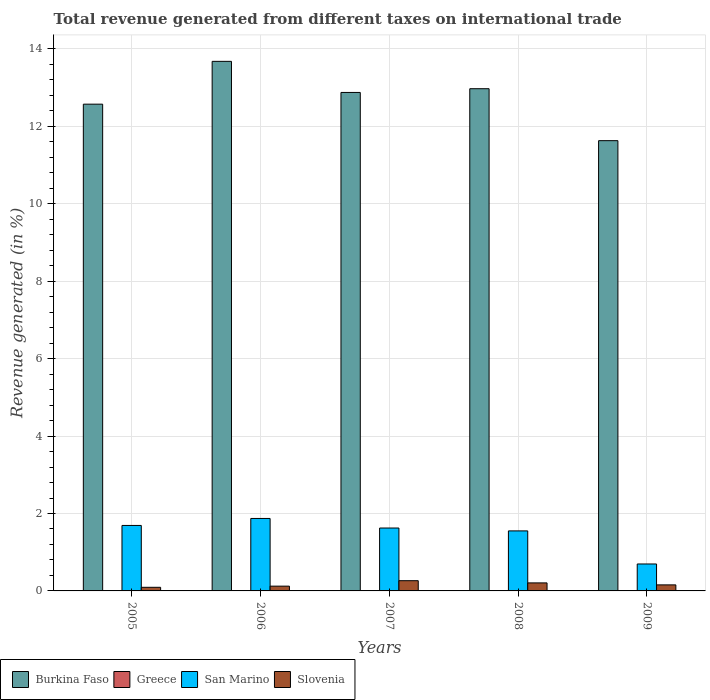How many different coloured bars are there?
Provide a succinct answer. 4. How many bars are there on the 5th tick from the left?
Make the answer very short. 4. How many bars are there on the 4th tick from the right?
Your answer should be compact. 4. What is the total revenue generated in San Marino in 2009?
Give a very brief answer. 0.7. Across all years, what is the maximum total revenue generated in Burkina Faso?
Offer a very short reply. 13.68. Across all years, what is the minimum total revenue generated in Burkina Faso?
Provide a short and direct response. 11.63. In which year was the total revenue generated in Burkina Faso minimum?
Make the answer very short. 2009. What is the total total revenue generated in Burkina Faso in the graph?
Your answer should be compact. 63.73. What is the difference between the total revenue generated in Burkina Faso in 2007 and that in 2009?
Give a very brief answer. 1.25. What is the difference between the total revenue generated in Greece in 2007 and the total revenue generated in San Marino in 2008?
Your answer should be compact. -1.54. What is the average total revenue generated in Burkina Faso per year?
Your answer should be very brief. 12.75. In the year 2005, what is the difference between the total revenue generated in Greece and total revenue generated in Slovenia?
Give a very brief answer. -0.09. What is the ratio of the total revenue generated in Burkina Faso in 2005 to that in 2007?
Provide a short and direct response. 0.98. What is the difference between the highest and the second highest total revenue generated in Burkina Faso?
Ensure brevity in your answer.  0.71. What is the difference between the highest and the lowest total revenue generated in Burkina Faso?
Make the answer very short. 2.05. Is the sum of the total revenue generated in San Marino in 2007 and 2008 greater than the maximum total revenue generated in Slovenia across all years?
Ensure brevity in your answer.  Yes. Is it the case that in every year, the sum of the total revenue generated in Burkina Faso and total revenue generated in Greece is greater than the sum of total revenue generated in Slovenia and total revenue generated in San Marino?
Your response must be concise. Yes. What does the 3rd bar from the left in 2008 represents?
Offer a very short reply. San Marino. What does the 1st bar from the right in 2006 represents?
Your response must be concise. Slovenia. How many years are there in the graph?
Keep it short and to the point. 5. What is the difference between two consecutive major ticks on the Y-axis?
Ensure brevity in your answer.  2. Are the values on the major ticks of Y-axis written in scientific E-notation?
Keep it short and to the point. No. Does the graph contain any zero values?
Keep it short and to the point. No. Does the graph contain grids?
Provide a short and direct response. Yes. What is the title of the graph?
Your answer should be very brief. Total revenue generated from different taxes on international trade. Does "Thailand" appear as one of the legend labels in the graph?
Ensure brevity in your answer.  No. What is the label or title of the Y-axis?
Offer a terse response. Revenue generated (in %). What is the Revenue generated (in %) in Burkina Faso in 2005?
Your answer should be compact. 12.57. What is the Revenue generated (in %) of Greece in 2005?
Ensure brevity in your answer.  0. What is the Revenue generated (in %) in San Marino in 2005?
Your answer should be compact. 1.69. What is the Revenue generated (in %) in Slovenia in 2005?
Provide a succinct answer. 0.09. What is the Revenue generated (in %) in Burkina Faso in 2006?
Your response must be concise. 13.68. What is the Revenue generated (in %) of Greece in 2006?
Offer a terse response. 0.01. What is the Revenue generated (in %) in San Marino in 2006?
Your response must be concise. 1.87. What is the Revenue generated (in %) of Slovenia in 2006?
Your answer should be very brief. 0.12. What is the Revenue generated (in %) in Burkina Faso in 2007?
Offer a terse response. 12.88. What is the Revenue generated (in %) in Greece in 2007?
Keep it short and to the point. 0.01. What is the Revenue generated (in %) of San Marino in 2007?
Make the answer very short. 1.62. What is the Revenue generated (in %) in Slovenia in 2007?
Give a very brief answer. 0.26. What is the Revenue generated (in %) in Burkina Faso in 2008?
Your answer should be compact. 12.97. What is the Revenue generated (in %) of Greece in 2008?
Your response must be concise. 0. What is the Revenue generated (in %) of San Marino in 2008?
Keep it short and to the point. 1.55. What is the Revenue generated (in %) of Slovenia in 2008?
Your answer should be very brief. 0.21. What is the Revenue generated (in %) in Burkina Faso in 2009?
Your response must be concise. 11.63. What is the Revenue generated (in %) of Greece in 2009?
Provide a succinct answer. 0. What is the Revenue generated (in %) in San Marino in 2009?
Keep it short and to the point. 0.7. What is the Revenue generated (in %) in Slovenia in 2009?
Your response must be concise. 0.16. Across all years, what is the maximum Revenue generated (in %) in Burkina Faso?
Ensure brevity in your answer.  13.68. Across all years, what is the maximum Revenue generated (in %) of Greece?
Your answer should be very brief. 0.01. Across all years, what is the maximum Revenue generated (in %) of San Marino?
Offer a very short reply. 1.87. Across all years, what is the maximum Revenue generated (in %) of Slovenia?
Keep it short and to the point. 0.26. Across all years, what is the minimum Revenue generated (in %) in Burkina Faso?
Your answer should be very brief. 11.63. Across all years, what is the minimum Revenue generated (in %) of Greece?
Provide a succinct answer. 0. Across all years, what is the minimum Revenue generated (in %) of San Marino?
Offer a terse response. 0.7. Across all years, what is the minimum Revenue generated (in %) in Slovenia?
Offer a very short reply. 0.09. What is the total Revenue generated (in %) in Burkina Faso in the graph?
Provide a short and direct response. 63.73. What is the total Revenue generated (in %) in Greece in the graph?
Provide a short and direct response. 0.02. What is the total Revenue generated (in %) in San Marino in the graph?
Offer a terse response. 7.43. What is the total Revenue generated (in %) in Slovenia in the graph?
Offer a terse response. 0.84. What is the difference between the Revenue generated (in %) in Burkina Faso in 2005 and that in 2006?
Keep it short and to the point. -1.11. What is the difference between the Revenue generated (in %) in Greece in 2005 and that in 2006?
Keep it short and to the point. -0. What is the difference between the Revenue generated (in %) in San Marino in 2005 and that in 2006?
Your response must be concise. -0.18. What is the difference between the Revenue generated (in %) of Slovenia in 2005 and that in 2006?
Provide a succinct answer. -0.03. What is the difference between the Revenue generated (in %) in Burkina Faso in 2005 and that in 2007?
Give a very brief answer. -0.3. What is the difference between the Revenue generated (in %) in Greece in 2005 and that in 2007?
Your response must be concise. -0. What is the difference between the Revenue generated (in %) in San Marino in 2005 and that in 2007?
Your response must be concise. 0.07. What is the difference between the Revenue generated (in %) in Slovenia in 2005 and that in 2007?
Offer a terse response. -0.17. What is the difference between the Revenue generated (in %) in Burkina Faso in 2005 and that in 2008?
Provide a succinct answer. -0.4. What is the difference between the Revenue generated (in %) in Greece in 2005 and that in 2008?
Your answer should be very brief. 0. What is the difference between the Revenue generated (in %) in San Marino in 2005 and that in 2008?
Keep it short and to the point. 0.14. What is the difference between the Revenue generated (in %) of Slovenia in 2005 and that in 2008?
Provide a short and direct response. -0.11. What is the difference between the Revenue generated (in %) in Burkina Faso in 2005 and that in 2009?
Ensure brevity in your answer.  0.94. What is the difference between the Revenue generated (in %) in Greece in 2005 and that in 2009?
Offer a very short reply. 0. What is the difference between the Revenue generated (in %) in San Marino in 2005 and that in 2009?
Provide a succinct answer. 1. What is the difference between the Revenue generated (in %) in Slovenia in 2005 and that in 2009?
Your answer should be very brief. -0.06. What is the difference between the Revenue generated (in %) of Burkina Faso in 2006 and that in 2007?
Give a very brief answer. 0.8. What is the difference between the Revenue generated (in %) in Greece in 2006 and that in 2007?
Your answer should be compact. -0. What is the difference between the Revenue generated (in %) of San Marino in 2006 and that in 2007?
Your answer should be very brief. 0.25. What is the difference between the Revenue generated (in %) in Slovenia in 2006 and that in 2007?
Give a very brief answer. -0.14. What is the difference between the Revenue generated (in %) in Burkina Faso in 2006 and that in 2008?
Keep it short and to the point. 0.71. What is the difference between the Revenue generated (in %) of Greece in 2006 and that in 2008?
Your response must be concise. 0. What is the difference between the Revenue generated (in %) in San Marino in 2006 and that in 2008?
Offer a very short reply. 0.32. What is the difference between the Revenue generated (in %) of Slovenia in 2006 and that in 2008?
Your response must be concise. -0.08. What is the difference between the Revenue generated (in %) in Burkina Faso in 2006 and that in 2009?
Your response must be concise. 2.05. What is the difference between the Revenue generated (in %) in Greece in 2006 and that in 2009?
Make the answer very short. 0. What is the difference between the Revenue generated (in %) in San Marino in 2006 and that in 2009?
Make the answer very short. 1.18. What is the difference between the Revenue generated (in %) of Slovenia in 2006 and that in 2009?
Your response must be concise. -0.03. What is the difference between the Revenue generated (in %) of Burkina Faso in 2007 and that in 2008?
Your response must be concise. -0.1. What is the difference between the Revenue generated (in %) in Greece in 2007 and that in 2008?
Make the answer very short. 0.01. What is the difference between the Revenue generated (in %) of San Marino in 2007 and that in 2008?
Offer a very short reply. 0.07. What is the difference between the Revenue generated (in %) of Slovenia in 2007 and that in 2008?
Ensure brevity in your answer.  0.06. What is the difference between the Revenue generated (in %) in Burkina Faso in 2007 and that in 2009?
Make the answer very short. 1.25. What is the difference between the Revenue generated (in %) in Greece in 2007 and that in 2009?
Keep it short and to the point. 0.01. What is the difference between the Revenue generated (in %) in San Marino in 2007 and that in 2009?
Your answer should be compact. 0.93. What is the difference between the Revenue generated (in %) of Slovenia in 2007 and that in 2009?
Ensure brevity in your answer.  0.11. What is the difference between the Revenue generated (in %) in Burkina Faso in 2008 and that in 2009?
Provide a short and direct response. 1.34. What is the difference between the Revenue generated (in %) in San Marino in 2008 and that in 2009?
Give a very brief answer. 0.85. What is the difference between the Revenue generated (in %) of Slovenia in 2008 and that in 2009?
Give a very brief answer. 0.05. What is the difference between the Revenue generated (in %) in Burkina Faso in 2005 and the Revenue generated (in %) in Greece in 2006?
Keep it short and to the point. 12.57. What is the difference between the Revenue generated (in %) of Burkina Faso in 2005 and the Revenue generated (in %) of San Marino in 2006?
Keep it short and to the point. 10.7. What is the difference between the Revenue generated (in %) of Burkina Faso in 2005 and the Revenue generated (in %) of Slovenia in 2006?
Offer a terse response. 12.45. What is the difference between the Revenue generated (in %) of Greece in 2005 and the Revenue generated (in %) of San Marino in 2006?
Keep it short and to the point. -1.87. What is the difference between the Revenue generated (in %) of Greece in 2005 and the Revenue generated (in %) of Slovenia in 2006?
Your answer should be compact. -0.12. What is the difference between the Revenue generated (in %) of San Marino in 2005 and the Revenue generated (in %) of Slovenia in 2006?
Give a very brief answer. 1.57. What is the difference between the Revenue generated (in %) of Burkina Faso in 2005 and the Revenue generated (in %) of Greece in 2007?
Make the answer very short. 12.56. What is the difference between the Revenue generated (in %) of Burkina Faso in 2005 and the Revenue generated (in %) of San Marino in 2007?
Your answer should be very brief. 10.95. What is the difference between the Revenue generated (in %) in Burkina Faso in 2005 and the Revenue generated (in %) in Slovenia in 2007?
Your answer should be very brief. 12.31. What is the difference between the Revenue generated (in %) in Greece in 2005 and the Revenue generated (in %) in San Marino in 2007?
Your answer should be very brief. -1.62. What is the difference between the Revenue generated (in %) of Greece in 2005 and the Revenue generated (in %) of Slovenia in 2007?
Keep it short and to the point. -0.26. What is the difference between the Revenue generated (in %) of San Marino in 2005 and the Revenue generated (in %) of Slovenia in 2007?
Make the answer very short. 1.43. What is the difference between the Revenue generated (in %) of Burkina Faso in 2005 and the Revenue generated (in %) of Greece in 2008?
Ensure brevity in your answer.  12.57. What is the difference between the Revenue generated (in %) in Burkina Faso in 2005 and the Revenue generated (in %) in San Marino in 2008?
Offer a very short reply. 11.02. What is the difference between the Revenue generated (in %) in Burkina Faso in 2005 and the Revenue generated (in %) in Slovenia in 2008?
Provide a succinct answer. 12.37. What is the difference between the Revenue generated (in %) of Greece in 2005 and the Revenue generated (in %) of San Marino in 2008?
Offer a very short reply. -1.55. What is the difference between the Revenue generated (in %) of Greece in 2005 and the Revenue generated (in %) of Slovenia in 2008?
Your answer should be very brief. -0.2. What is the difference between the Revenue generated (in %) in San Marino in 2005 and the Revenue generated (in %) in Slovenia in 2008?
Give a very brief answer. 1.48. What is the difference between the Revenue generated (in %) in Burkina Faso in 2005 and the Revenue generated (in %) in Greece in 2009?
Provide a short and direct response. 12.57. What is the difference between the Revenue generated (in %) in Burkina Faso in 2005 and the Revenue generated (in %) in San Marino in 2009?
Ensure brevity in your answer.  11.88. What is the difference between the Revenue generated (in %) in Burkina Faso in 2005 and the Revenue generated (in %) in Slovenia in 2009?
Make the answer very short. 12.42. What is the difference between the Revenue generated (in %) in Greece in 2005 and the Revenue generated (in %) in San Marino in 2009?
Your answer should be compact. -0.69. What is the difference between the Revenue generated (in %) in Greece in 2005 and the Revenue generated (in %) in Slovenia in 2009?
Keep it short and to the point. -0.15. What is the difference between the Revenue generated (in %) in San Marino in 2005 and the Revenue generated (in %) in Slovenia in 2009?
Provide a succinct answer. 1.54. What is the difference between the Revenue generated (in %) of Burkina Faso in 2006 and the Revenue generated (in %) of Greece in 2007?
Make the answer very short. 13.67. What is the difference between the Revenue generated (in %) in Burkina Faso in 2006 and the Revenue generated (in %) in San Marino in 2007?
Keep it short and to the point. 12.05. What is the difference between the Revenue generated (in %) in Burkina Faso in 2006 and the Revenue generated (in %) in Slovenia in 2007?
Ensure brevity in your answer.  13.41. What is the difference between the Revenue generated (in %) in Greece in 2006 and the Revenue generated (in %) in San Marino in 2007?
Offer a terse response. -1.62. What is the difference between the Revenue generated (in %) of Greece in 2006 and the Revenue generated (in %) of Slovenia in 2007?
Offer a terse response. -0.26. What is the difference between the Revenue generated (in %) in San Marino in 2006 and the Revenue generated (in %) in Slovenia in 2007?
Ensure brevity in your answer.  1.61. What is the difference between the Revenue generated (in %) in Burkina Faso in 2006 and the Revenue generated (in %) in Greece in 2008?
Your answer should be very brief. 13.68. What is the difference between the Revenue generated (in %) of Burkina Faso in 2006 and the Revenue generated (in %) of San Marino in 2008?
Your response must be concise. 12.13. What is the difference between the Revenue generated (in %) of Burkina Faso in 2006 and the Revenue generated (in %) of Slovenia in 2008?
Offer a terse response. 13.47. What is the difference between the Revenue generated (in %) in Greece in 2006 and the Revenue generated (in %) in San Marino in 2008?
Provide a short and direct response. -1.55. What is the difference between the Revenue generated (in %) of Greece in 2006 and the Revenue generated (in %) of Slovenia in 2008?
Make the answer very short. -0.2. What is the difference between the Revenue generated (in %) in San Marino in 2006 and the Revenue generated (in %) in Slovenia in 2008?
Your answer should be compact. 1.66. What is the difference between the Revenue generated (in %) of Burkina Faso in 2006 and the Revenue generated (in %) of Greece in 2009?
Your response must be concise. 13.68. What is the difference between the Revenue generated (in %) in Burkina Faso in 2006 and the Revenue generated (in %) in San Marino in 2009?
Your answer should be compact. 12.98. What is the difference between the Revenue generated (in %) of Burkina Faso in 2006 and the Revenue generated (in %) of Slovenia in 2009?
Give a very brief answer. 13.52. What is the difference between the Revenue generated (in %) of Greece in 2006 and the Revenue generated (in %) of San Marino in 2009?
Provide a short and direct response. -0.69. What is the difference between the Revenue generated (in %) of Greece in 2006 and the Revenue generated (in %) of Slovenia in 2009?
Your response must be concise. -0.15. What is the difference between the Revenue generated (in %) in San Marino in 2006 and the Revenue generated (in %) in Slovenia in 2009?
Your response must be concise. 1.72. What is the difference between the Revenue generated (in %) in Burkina Faso in 2007 and the Revenue generated (in %) in Greece in 2008?
Keep it short and to the point. 12.87. What is the difference between the Revenue generated (in %) in Burkina Faso in 2007 and the Revenue generated (in %) in San Marino in 2008?
Your response must be concise. 11.33. What is the difference between the Revenue generated (in %) of Burkina Faso in 2007 and the Revenue generated (in %) of Slovenia in 2008?
Offer a terse response. 12.67. What is the difference between the Revenue generated (in %) of Greece in 2007 and the Revenue generated (in %) of San Marino in 2008?
Offer a terse response. -1.54. What is the difference between the Revenue generated (in %) in Greece in 2007 and the Revenue generated (in %) in Slovenia in 2008?
Make the answer very short. -0.2. What is the difference between the Revenue generated (in %) in San Marino in 2007 and the Revenue generated (in %) in Slovenia in 2008?
Offer a very short reply. 1.42. What is the difference between the Revenue generated (in %) in Burkina Faso in 2007 and the Revenue generated (in %) in Greece in 2009?
Offer a terse response. 12.87. What is the difference between the Revenue generated (in %) of Burkina Faso in 2007 and the Revenue generated (in %) of San Marino in 2009?
Your answer should be very brief. 12.18. What is the difference between the Revenue generated (in %) of Burkina Faso in 2007 and the Revenue generated (in %) of Slovenia in 2009?
Provide a short and direct response. 12.72. What is the difference between the Revenue generated (in %) of Greece in 2007 and the Revenue generated (in %) of San Marino in 2009?
Provide a short and direct response. -0.69. What is the difference between the Revenue generated (in %) in Greece in 2007 and the Revenue generated (in %) in Slovenia in 2009?
Provide a short and direct response. -0.15. What is the difference between the Revenue generated (in %) in San Marino in 2007 and the Revenue generated (in %) in Slovenia in 2009?
Ensure brevity in your answer.  1.47. What is the difference between the Revenue generated (in %) in Burkina Faso in 2008 and the Revenue generated (in %) in Greece in 2009?
Provide a succinct answer. 12.97. What is the difference between the Revenue generated (in %) of Burkina Faso in 2008 and the Revenue generated (in %) of San Marino in 2009?
Ensure brevity in your answer.  12.28. What is the difference between the Revenue generated (in %) of Burkina Faso in 2008 and the Revenue generated (in %) of Slovenia in 2009?
Your answer should be very brief. 12.82. What is the difference between the Revenue generated (in %) in Greece in 2008 and the Revenue generated (in %) in San Marino in 2009?
Your answer should be compact. -0.69. What is the difference between the Revenue generated (in %) in Greece in 2008 and the Revenue generated (in %) in Slovenia in 2009?
Provide a short and direct response. -0.15. What is the difference between the Revenue generated (in %) in San Marino in 2008 and the Revenue generated (in %) in Slovenia in 2009?
Your answer should be compact. 1.39. What is the average Revenue generated (in %) in Burkina Faso per year?
Keep it short and to the point. 12.75. What is the average Revenue generated (in %) in Greece per year?
Make the answer very short. 0. What is the average Revenue generated (in %) of San Marino per year?
Make the answer very short. 1.49. What is the average Revenue generated (in %) of Slovenia per year?
Your response must be concise. 0.17. In the year 2005, what is the difference between the Revenue generated (in %) in Burkina Faso and Revenue generated (in %) in Greece?
Provide a succinct answer. 12.57. In the year 2005, what is the difference between the Revenue generated (in %) of Burkina Faso and Revenue generated (in %) of San Marino?
Ensure brevity in your answer.  10.88. In the year 2005, what is the difference between the Revenue generated (in %) of Burkina Faso and Revenue generated (in %) of Slovenia?
Your answer should be very brief. 12.48. In the year 2005, what is the difference between the Revenue generated (in %) of Greece and Revenue generated (in %) of San Marino?
Offer a very short reply. -1.69. In the year 2005, what is the difference between the Revenue generated (in %) in Greece and Revenue generated (in %) in Slovenia?
Keep it short and to the point. -0.09. In the year 2005, what is the difference between the Revenue generated (in %) in San Marino and Revenue generated (in %) in Slovenia?
Your answer should be compact. 1.6. In the year 2006, what is the difference between the Revenue generated (in %) of Burkina Faso and Revenue generated (in %) of Greece?
Your answer should be compact. 13.67. In the year 2006, what is the difference between the Revenue generated (in %) in Burkina Faso and Revenue generated (in %) in San Marino?
Offer a very short reply. 11.81. In the year 2006, what is the difference between the Revenue generated (in %) of Burkina Faso and Revenue generated (in %) of Slovenia?
Your response must be concise. 13.56. In the year 2006, what is the difference between the Revenue generated (in %) of Greece and Revenue generated (in %) of San Marino?
Offer a terse response. -1.87. In the year 2006, what is the difference between the Revenue generated (in %) in Greece and Revenue generated (in %) in Slovenia?
Your answer should be compact. -0.12. In the year 2006, what is the difference between the Revenue generated (in %) of San Marino and Revenue generated (in %) of Slovenia?
Ensure brevity in your answer.  1.75. In the year 2007, what is the difference between the Revenue generated (in %) of Burkina Faso and Revenue generated (in %) of Greece?
Provide a short and direct response. 12.87. In the year 2007, what is the difference between the Revenue generated (in %) in Burkina Faso and Revenue generated (in %) in San Marino?
Provide a short and direct response. 11.25. In the year 2007, what is the difference between the Revenue generated (in %) of Burkina Faso and Revenue generated (in %) of Slovenia?
Ensure brevity in your answer.  12.61. In the year 2007, what is the difference between the Revenue generated (in %) of Greece and Revenue generated (in %) of San Marino?
Offer a very short reply. -1.62. In the year 2007, what is the difference between the Revenue generated (in %) in Greece and Revenue generated (in %) in Slovenia?
Offer a terse response. -0.26. In the year 2007, what is the difference between the Revenue generated (in %) in San Marino and Revenue generated (in %) in Slovenia?
Your response must be concise. 1.36. In the year 2008, what is the difference between the Revenue generated (in %) in Burkina Faso and Revenue generated (in %) in Greece?
Your response must be concise. 12.97. In the year 2008, what is the difference between the Revenue generated (in %) of Burkina Faso and Revenue generated (in %) of San Marino?
Offer a terse response. 11.42. In the year 2008, what is the difference between the Revenue generated (in %) in Burkina Faso and Revenue generated (in %) in Slovenia?
Your answer should be very brief. 12.77. In the year 2008, what is the difference between the Revenue generated (in %) in Greece and Revenue generated (in %) in San Marino?
Give a very brief answer. -1.55. In the year 2008, what is the difference between the Revenue generated (in %) in Greece and Revenue generated (in %) in Slovenia?
Ensure brevity in your answer.  -0.2. In the year 2008, what is the difference between the Revenue generated (in %) in San Marino and Revenue generated (in %) in Slovenia?
Provide a short and direct response. 1.34. In the year 2009, what is the difference between the Revenue generated (in %) of Burkina Faso and Revenue generated (in %) of Greece?
Your answer should be compact. 11.63. In the year 2009, what is the difference between the Revenue generated (in %) in Burkina Faso and Revenue generated (in %) in San Marino?
Give a very brief answer. 10.93. In the year 2009, what is the difference between the Revenue generated (in %) in Burkina Faso and Revenue generated (in %) in Slovenia?
Your answer should be compact. 11.47. In the year 2009, what is the difference between the Revenue generated (in %) in Greece and Revenue generated (in %) in San Marino?
Give a very brief answer. -0.69. In the year 2009, what is the difference between the Revenue generated (in %) in Greece and Revenue generated (in %) in Slovenia?
Your response must be concise. -0.15. In the year 2009, what is the difference between the Revenue generated (in %) of San Marino and Revenue generated (in %) of Slovenia?
Offer a very short reply. 0.54. What is the ratio of the Revenue generated (in %) in Burkina Faso in 2005 to that in 2006?
Offer a very short reply. 0.92. What is the ratio of the Revenue generated (in %) in Greece in 2005 to that in 2006?
Provide a short and direct response. 0.82. What is the ratio of the Revenue generated (in %) of San Marino in 2005 to that in 2006?
Offer a very short reply. 0.9. What is the ratio of the Revenue generated (in %) in Slovenia in 2005 to that in 2006?
Offer a very short reply. 0.76. What is the ratio of the Revenue generated (in %) in Burkina Faso in 2005 to that in 2007?
Provide a succinct answer. 0.98. What is the ratio of the Revenue generated (in %) in Greece in 2005 to that in 2007?
Your response must be concise. 0.52. What is the ratio of the Revenue generated (in %) in San Marino in 2005 to that in 2007?
Your answer should be very brief. 1.04. What is the ratio of the Revenue generated (in %) of Slovenia in 2005 to that in 2007?
Offer a terse response. 0.35. What is the ratio of the Revenue generated (in %) in Burkina Faso in 2005 to that in 2008?
Ensure brevity in your answer.  0.97. What is the ratio of the Revenue generated (in %) of Greece in 2005 to that in 2008?
Your answer should be very brief. 1.89. What is the ratio of the Revenue generated (in %) of San Marino in 2005 to that in 2008?
Give a very brief answer. 1.09. What is the ratio of the Revenue generated (in %) of Slovenia in 2005 to that in 2008?
Provide a succinct answer. 0.45. What is the ratio of the Revenue generated (in %) in Burkina Faso in 2005 to that in 2009?
Give a very brief answer. 1.08. What is the ratio of the Revenue generated (in %) in Greece in 2005 to that in 2009?
Provide a short and direct response. 3.52. What is the ratio of the Revenue generated (in %) in San Marino in 2005 to that in 2009?
Offer a very short reply. 2.43. What is the ratio of the Revenue generated (in %) of Slovenia in 2005 to that in 2009?
Make the answer very short. 0.6. What is the ratio of the Revenue generated (in %) of Burkina Faso in 2006 to that in 2007?
Offer a terse response. 1.06. What is the ratio of the Revenue generated (in %) in Greece in 2006 to that in 2007?
Keep it short and to the point. 0.63. What is the ratio of the Revenue generated (in %) of San Marino in 2006 to that in 2007?
Give a very brief answer. 1.15. What is the ratio of the Revenue generated (in %) of Slovenia in 2006 to that in 2007?
Your answer should be very brief. 0.47. What is the ratio of the Revenue generated (in %) in Burkina Faso in 2006 to that in 2008?
Your response must be concise. 1.05. What is the ratio of the Revenue generated (in %) of Greece in 2006 to that in 2008?
Provide a short and direct response. 2.32. What is the ratio of the Revenue generated (in %) in San Marino in 2006 to that in 2008?
Give a very brief answer. 1.21. What is the ratio of the Revenue generated (in %) in Slovenia in 2006 to that in 2008?
Keep it short and to the point. 0.6. What is the ratio of the Revenue generated (in %) of Burkina Faso in 2006 to that in 2009?
Make the answer very short. 1.18. What is the ratio of the Revenue generated (in %) in Greece in 2006 to that in 2009?
Make the answer very short. 4.31. What is the ratio of the Revenue generated (in %) of San Marino in 2006 to that in 2009?
Offer a terse response. 2.69. What is the ratio of the Revenue generated (in %) of Slovenia in 2006 to that in 2009?
Provide a short and direct response. 0.79. What is the ratio of the Revenue generated (in %) in Burkina Faso in 2007 to that in 2008?
Your response must be concise. 0.99. What is the ratio of the Revenue generated (in %) of Greece in 2007 to that in 2008?
Provide a short and direct response. 3.65. What is the ratio of the Revenue generated (in %) in San Marino in 2007 to that in 2008?
Provide a succinct answer. 1.05. What is the ratio of the Revenue generated (in %) in Slovenia in 2007 to that in 2008?
Ensure brevity in your answer.  1.28. What is the ratio of the Revenue generated (in %) of Burkina Faso in 2007 to that in 2009?
Provide a succinct answer. 1.11. What is the ratio of the Revenue generated (in %) in Greece in 2007 to that in 2009?
Keep it short and to the point. 6.79. What is the ratio of the Revenue generated (in %) of San Marino in 2007 to that in 2009?
Ensure brevity in your answer.  2.33. What is the ratio of the Revenue generated (in %) in Slovenia in 2007 to that in 2009?
Ensure brevity in your answer.  1.69. What is the ratio of the Revenue generated (in %) in Burkina Faso in 2008 to that in 2009?
Provide a short and direct response. 1.12. What is the ratio of the Revenue generated (in %) of Greece in 2008 to that in 2009?
Give a very brief answer. 1.86. What is the ratio of the Revenue generated (in %) in San Marino in 2008 to that in 2009?
Your answer should be compact. 2.23. What is the ratio of the Revenue generated (in %) in Slovenia in 2008 to that in 2009?
Your response must be concise. 1.33. What is the difference between the highest and the second highest Revenue generated (in %) of Burkina Faso?
Give a very brief answer. 0.71. What is the difference between the highest and the second highest Revenue generated (in %) of Greece?
Offer a very short reply. 0. What is the difference between the highest and the second highest Revenue generated (in %) in San Marino?
Offer a terse response. 0.18. What is the difference between the highest and the second highest Revenue generated (in %) in Slovenia?
Offer a terse response. 0.06. What is the difference between the highest and the lowest Revenue generated (in %) of Burkina Faso?
Offer a terse response. 2.05. What is the difference between the highest and the lowest Revenue generated (in %) of Greece?
Make the answer very short. 0.01. What is the difference between the highest and the lowest Revenue generated (in %) in San Marino?
Your answer should be very brief. 1.18. What is the difference between the highest and the lowest Revenue generated (in %) of Slovenia?
Your answer should be compact. 0.17. 